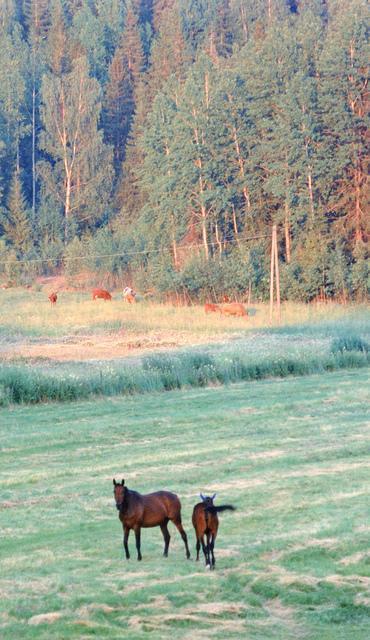How many horses are there?
Give a very brief answer. 2. How many giraffes are there?
Give a very brief answer. 0. 